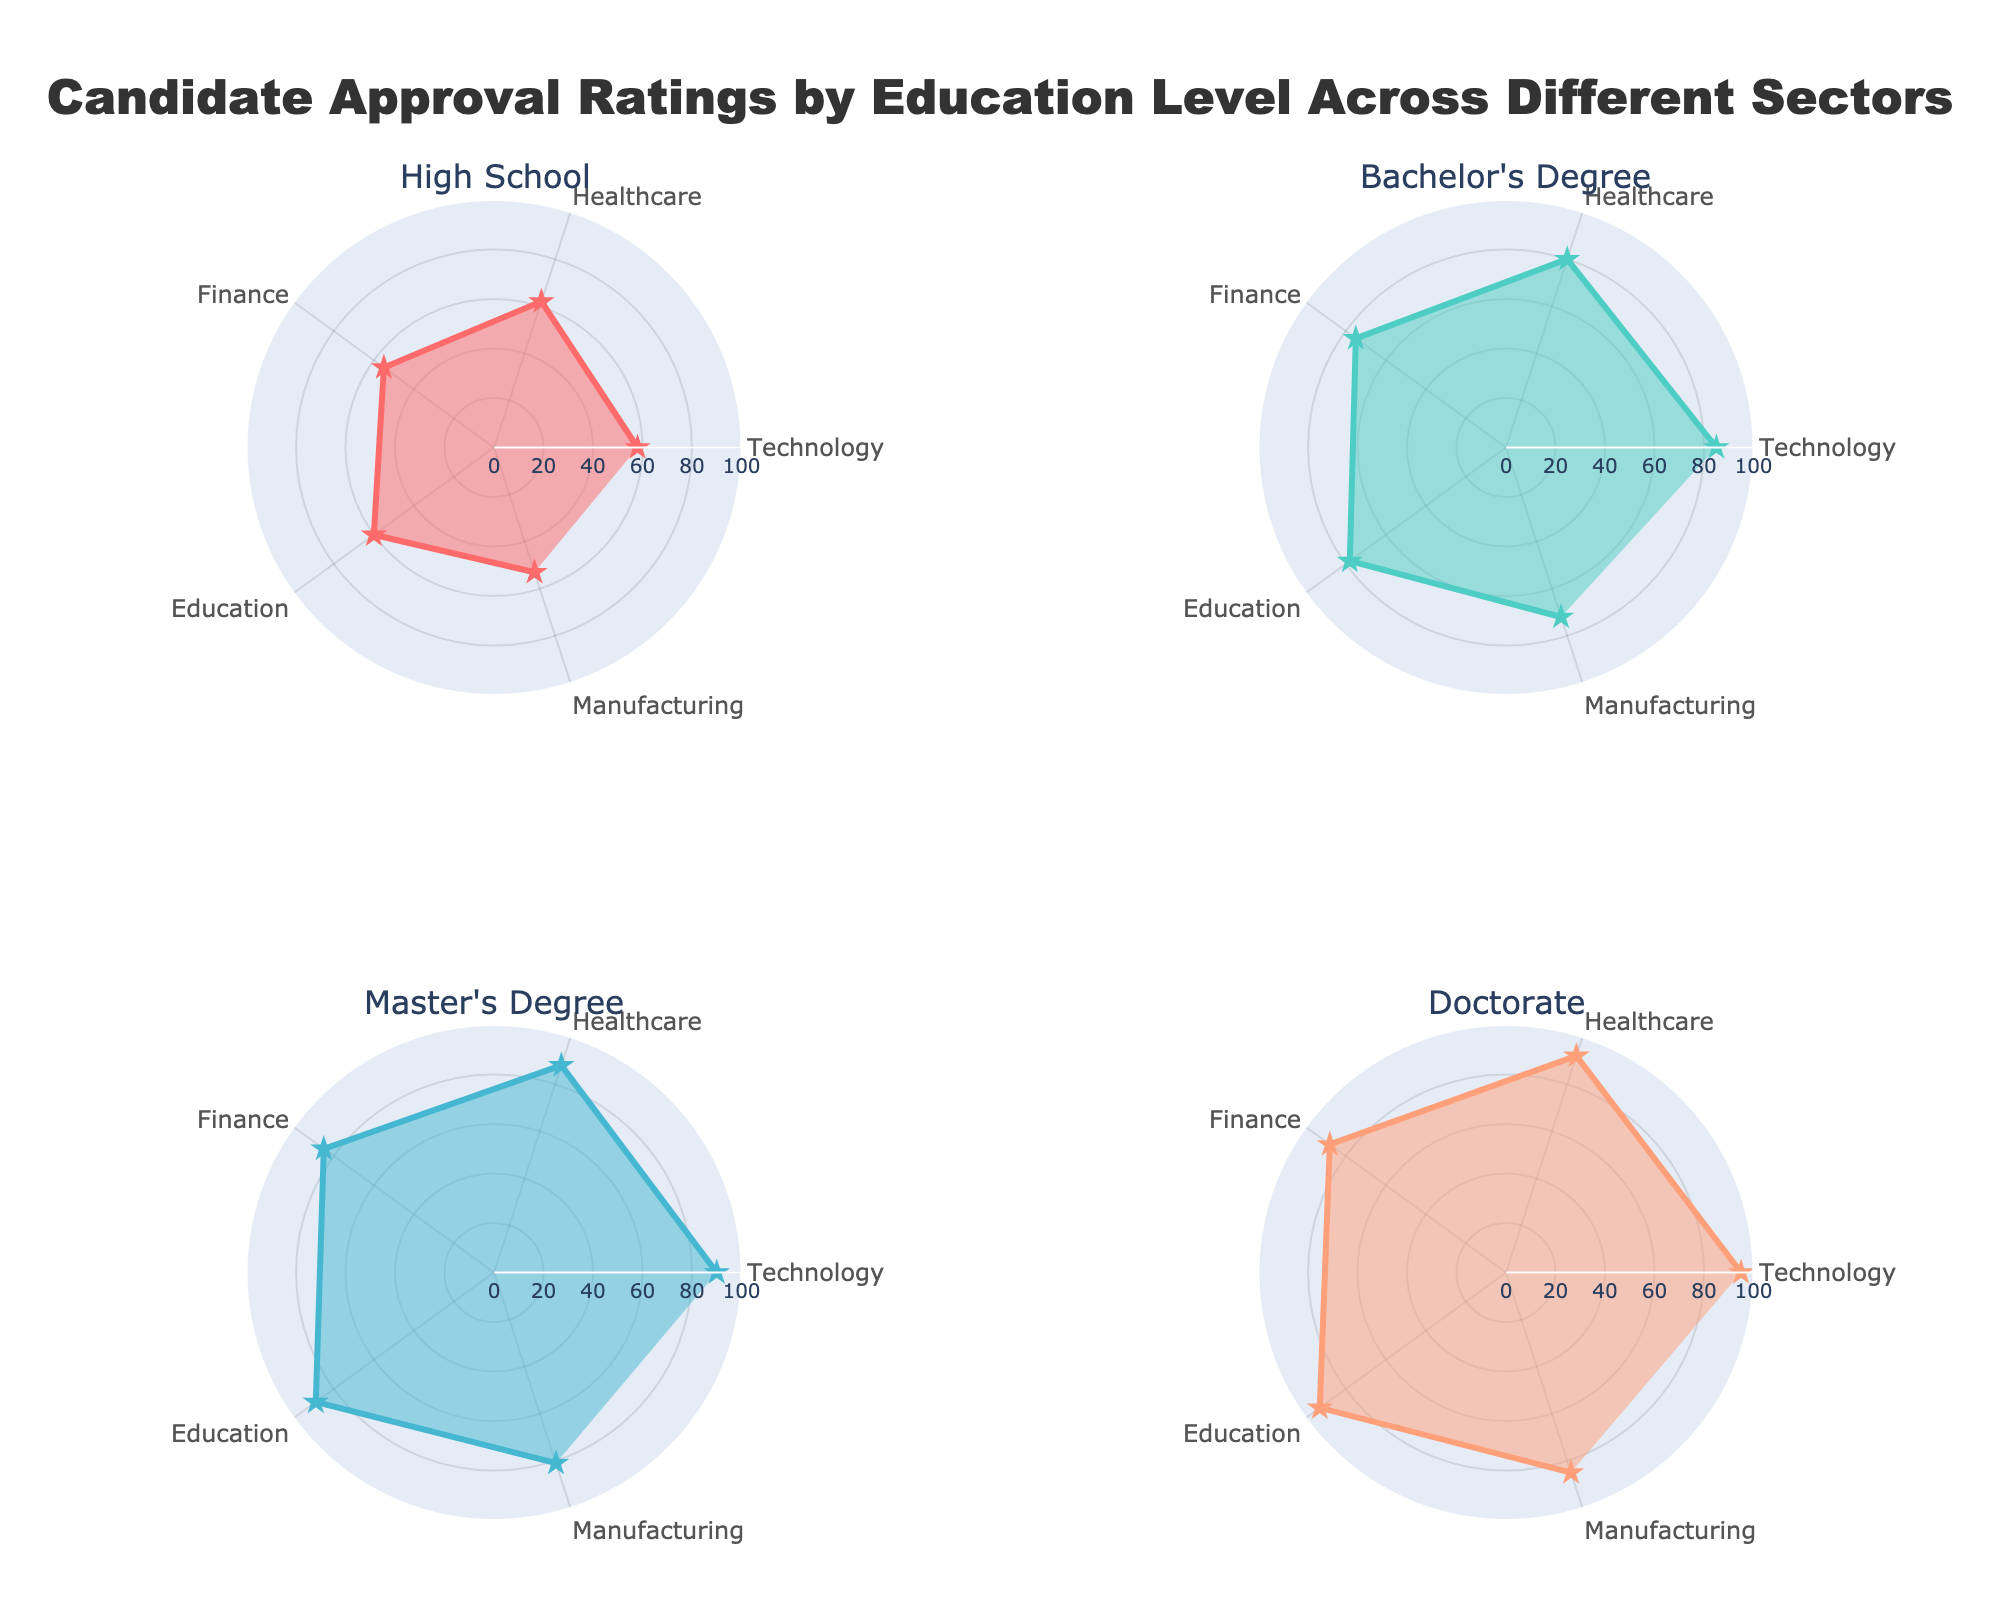What is the title of the figure? The title of the figure is located at the top center and describes what the figure is about.
Answer: Candidate Approval Ratings by Education Level Across Different Sectors Which sector has the highest approval rating for candidates with a High School education? From the Polar Chart for the High School education level, look for the sector with the highest radial value.
Answer: Healthcare What is the average approval rating for candidates with a Bachelor's Degree across all sectors? Sum all the approval ratings for sectors in the Bachelor's Degree Polar Chart and divide by the number of sectors. Calculation: (85+80+75+78+72) / 5 = 78
Answer: 78 Which education level has the highest approval rating overall, and in which sector? Check all Polar Charts and identify the education level and sector with the maximum radial value. The highest approval rating is 95 for Doctorate candidates in the Technology sector.
Answer: Doctorate in Technology How does the approval rating in the Healthcare sector compare between Master's Degree and Doctorate candidates? Compare the Healthcare sector radial values for Master's Degree and Doctorate Polar Charts: Master's Degree has 88, and Doctorate has 92.
Answer: Doctorate candidates have a higher rating What is the difference between the highest and lowest approval rating for the Technology sector across all education levels? Identify the highest (Doctorate at 95) and lowest (High School at 58) approval ratings in the Technology sector. Difference: 95 - 58 = 37
Answer: 37 Are approval ratings in the Manufacturing sector consistently higher or lower for more advanced education levels? Compare approval ratings in the Manufacturing sector across education levels. Higher ratings generally correspond to more advanced education: High School (53), Bachelor's (72), Master's (81), Doctorate (85).
Answer: Higher Which education level shows the smallest range in approval ratings across all sectors? Calculate the range (difference between the highest and lowest approval ratings) for each education level: High School (62 - 53 = 9), Bachelor's (85 - 72 = 13), Master's (90 - 81 = 9), Doctorate (95 - 85 = 10). Smallest range is: 9.
Answer: High School and Master's Degree both have the smallest range What is the median approval rating for Master's Degree candidates? Sort the approval ratings for Master's Degree and find the middle value: 90, 88, 85, 89, 81. Median is the middle value, i.e., 88.
Answer: 88 Which sector stands out by having lower approval ratings for less advanced education levels but higher ratings for advanced education levels? Compare differences in approval ratings between High School and Doctorate levels for all sectors. Technology, with 58 (High School) to 95 (Doctorate), shows the most significant change.
Answer: Technology 